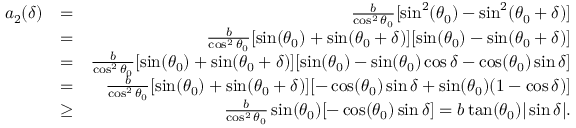<formula> <loc_0><loc_0><loc_500><loc_500>\begin{array} { r l r } { a _ { 2 } ( \delta ) } & { = } & { \frac { b } { \cos ^ { 2 } \theta _ { 0 } } [ \sin ^ { 2 } ( \theta _ { 0 } ) - \sin ^ { 2 } ( \theta _ { 0 } + \delta ) ] } \\ & { = } & { \frac { b } { \cos ^ { 2 } \theta _ { 0 } } [ \sin ( \theta _ { 0 } ) + \sin ( \theta _ { 0 } + \delta ) ] [ \sin ( \theta _ { 0 } ) - \sin ( \theta _ { 0 } + \delta ) ] } \\ & { = } & { \frac { b } { \cos ^ { 2 } \theta _ { 0 } } [ \sin ( \theta _ { 0 } ) + \sin ( \theta _ { 0 } + \delta ) ] [ \sin ( \theta _ { 0 } ) - \sin ( \theta _ { 0 } ) \cos \delta - \cos ( \theta _ { 0 } ) \sin \delta ] } \\ & { = } & { \frac { b } { \cos ^ { 2 } \theta _ { 0 } } [ \sin ( \theta _ { 0 } ) + \sin ( \theta _ { 0 } + \delta ) ] [ - \cos ( \theta _ { 0 } ) \sin \delta + \sin ( \theta _ { 0 } ) ( 1 - \cos \delta ) ] } \\ & { \geq } & { \frac { b } { \cos ^ { 2 } \theta _ { 0 } } \sin ( \theta _ { 0 } ) [ - \cos ( \theta _ { 0 } ) \sin \delta ] = b \tan ( \theta _ { 0 } ) | \sin \delta | . } \end{array}</formula> 